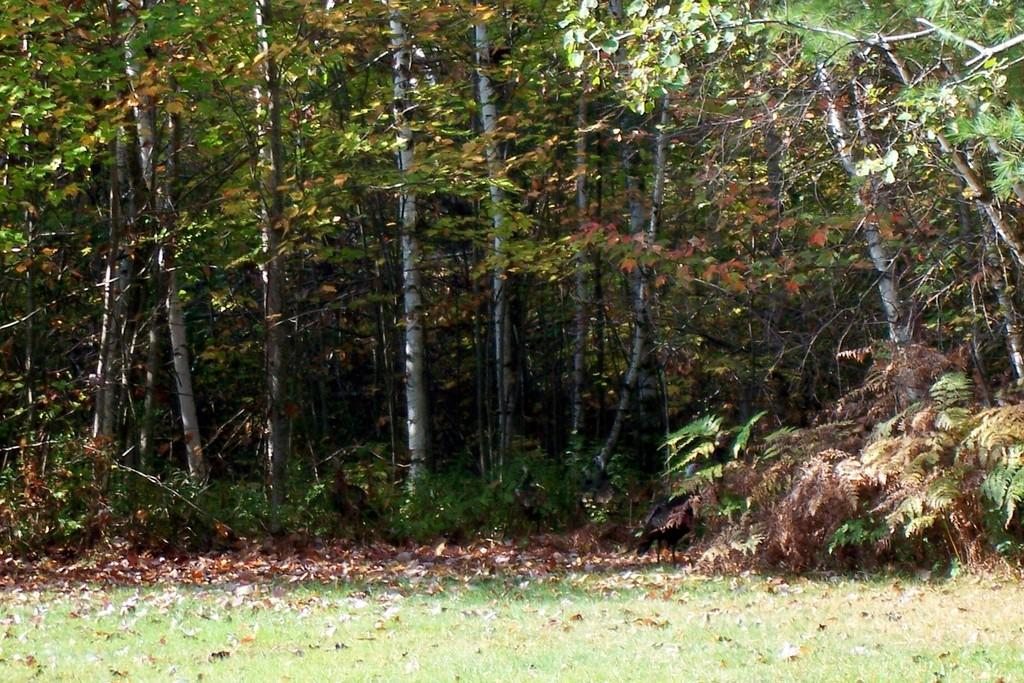What type of vegetation is on the ground in the image? There is grass and leaves on the ground in the image. What can be seen in the background of the image? There are plants and trees in the background of the image. What type of vegetable is growing on the bed in the image? There is no bed or vegetable present in the image. What idea does the image represent? The image does not represent an idea; it is a visual representation of grass, leaves, plants, and trees. 